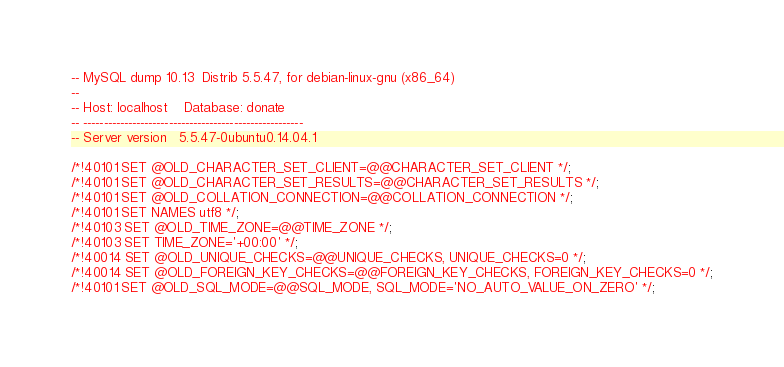Convert code to text. <code><loc_0><loc_0><loc_500><loc_500><_SQL_>-- MySQL dump 10.13  Distrib 5.5.47, for debian-linux-gnu (x86_64)
--
-- Host: localhost    Database: donate
-- ------------------------------------------------------
-- Server version	5.5.47-0ubuntu0.14.04.1

/*!40101 SET @OLD_CHARACTER_SET_CLIENT=@@CHARACTER_SET_CLIENT */;
/*!40101 SET @OLD_CHARACTER_SET_RESULTS=@@CHARACTER_SET_RESULTS */;
/*!40101 SET @OLD_COLLATION_CONNECTION=@@COLLATION_CONNECTION */;
/*!40101 SET NAMES utf8 */;
/*!40103 SET @OLD_TIME_ZONE=@@TIME_ZONE */;
/*!40103 SET TIME_ZONE='+00:00' */;
/*!40014 SET @OLD_UNIQUE_CHECKS=@@UNIQUE_CHECKS, UNIQUE_CHECKS=0 */;
/*!40014 SET @OLD_FOREIGN_KEY_CHECKS=@@FOREIGN_KEY_CHECKS, FOREIGN_KEY_CHECKS=0 */;
/*!40101 SET @OLD_SQL_MODE=@@SQL_MODE, SQL_MODE='NO_AUTO_VALUE_ON_ZERO' */;</code> 